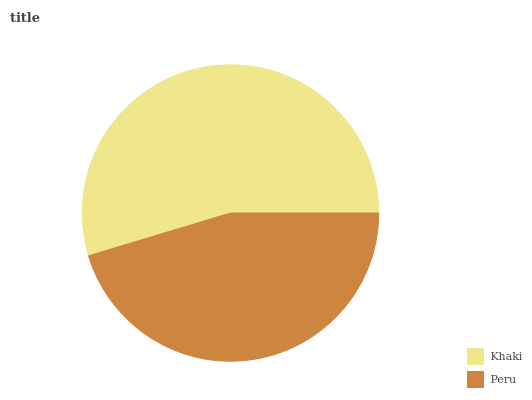Is Peru the minimum?
Answer yes or no. Yes. Is Khaki the maximum?
Answer yes or no. Yes. Is Peru the maximum?
Answer yes or no. No. Is Khaki greater than Peru?
Answer yes or no. Yes. Is Peru less than Khaki?
Answer yes or no. Yes. Is Peru greater than Khaki?
Answer yes or no. No. Is Khaki less than Peru?
Answer yes or no. No. Is Khaki the high median?
Answer yes or no. Yes. Is Peru the low median?
Answer yes or no. Yes. Is Peru the high median?
Answer yes or no. No. Is Khaki the low median?
Answer yes or no. No. 